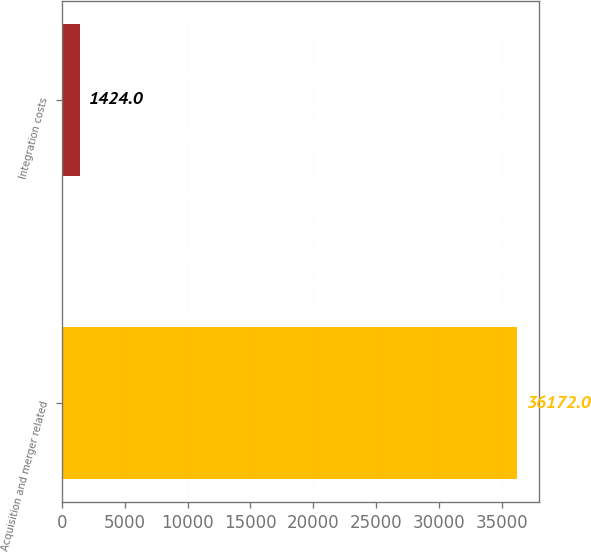Convert chart to OTSL. <chart><loc_0><loc_0><loc_500><loc_500><bar_chart><fcel>Acquisition and merger related<fcel>Integration costs<nl><fcel>36172<fcel>1424<nl></chart> 